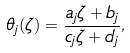<formula> <loc_0><loc_0><loc_500><loc_500>\theta _ { j } ( \zeta ) = \frac { a _ { j } \zeta + b _ { j } } { c _ { j } \zeta + d _ { j } } ,</formula> 